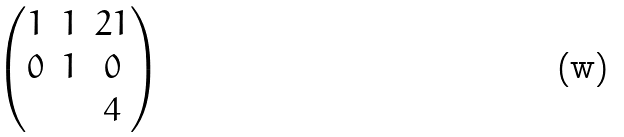<formula> <loc_0><loc_0><loc_500><loc_500>\begin{pmatrix} 1 & 1 & 2 1 \\ 0 & 1 & 0 \\ & & 4 \end{pmatrix}</formula> 